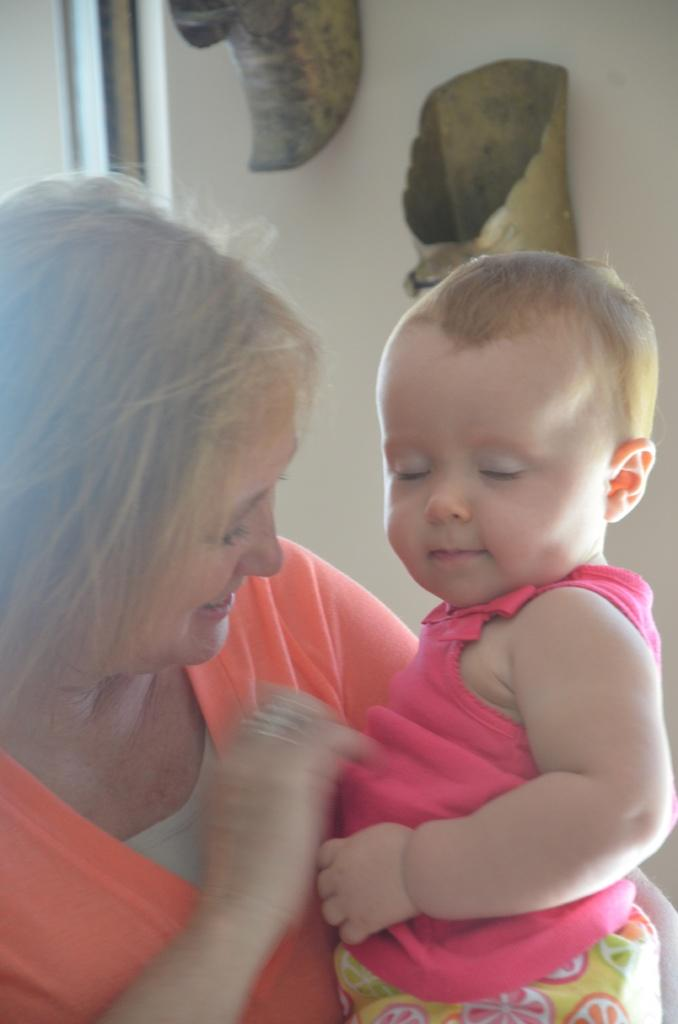Who is the main subject in the image? There is a woman in the image. What is the woman doing in the image? The woman is carrying a child. What can be seen in the background of the image? There are decorations on a wall in the background of the image. What type of quince is being used as a decoration on the wall in the image? There is no quince present in the image; the decorations on the wall are not specified. 